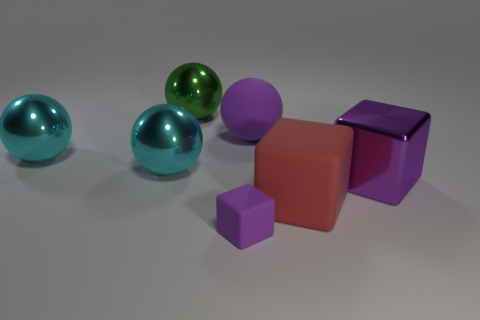Subtract all red balls. Subtract all purple cubes. How many balls are left? 4 Add 2 big gray objects. How many objects exist? 9 Subtract all spheres. How many objects are left? 3 Subtract 0 gray cylinders. How many objects are left? 7 Subtract all matte blocks. Subtract all tiny blue metallic spheres. How many objects are left? 5 Add 6 big purple shiny things. How many big purple shiny things are left? 7 Add 5 large cyan balls. How many large cyan balls exist? 7 